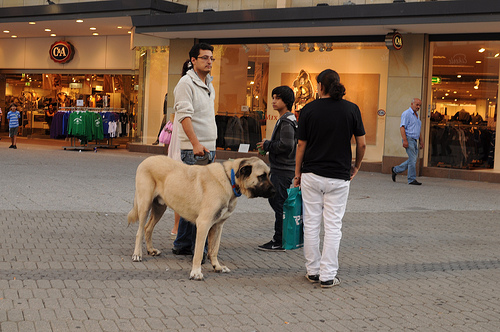Are there chairs to the left of the woman that is wearing a shirt?
Answer the question using a single word or phrase. No Who is wearing a shirt? Woman Is the man to the left of the woman holding onto a dog? Yes Is the animal to the left of the bag small or large? Large Is the kid to the left or to the right of the man that is on the right of the picture? Left Who is older, the woman or the child? Woman What is the animal that the man that is to the left of the woman is holding onto? Dog Is the jacket gray? Yes Are there dogs to the right of the bag the woman is holding? No What is the animal to the left of the child that is in the middle? Dog What animal is the man to the left of the bag holding onto? Dog Do you see horses or dogs that are large? Yes What type of animal is wearing a collar? Dog Is the kid to the right or to the left of the person that is wearing a shirt? Left What color do you think the shirt the woman is wearing has? Black 